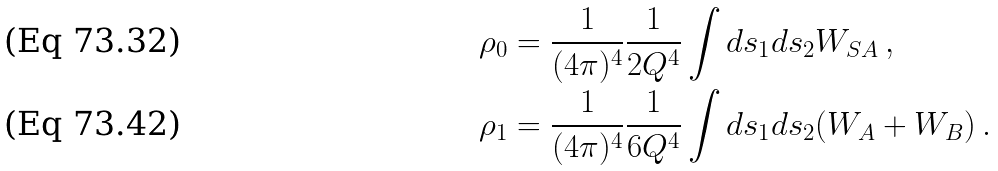<formula> <loc_0><loc_0><loc_500><loc_500>\rho _ { 0 } & = \frac { 1 } { ( 4 \pi ) ^ { 4 } } \frac { 1 } { 2 Q ^ { 4 } } \int d s _ { 1 } d s _ { 2 } W _ { S A } \, , \\ \rho _ { 1 } & = \frac { 1 } { ( 4 \pi ) ^ { 4 } } \frac { 1 } { 6 Q ^ { 4 } } \int d s _ { 1 } d s _ { 2 } ( W _ { A } + W _ { B } ) \, .</formula> 